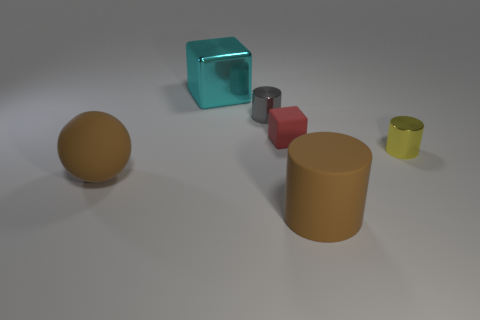There is a yellow shiny thing that is the same size as the gray metal object; what shape is it?
Provide a short and direct response. Cylinder. Is the number of big metallic things less than the number of brown matte objects?
Make the answer very short. Yes. Is there a brown cylinder that is left of the rubber thing in front of the brown ball?
Offer a very short reply. No. Is there a tiny gray metal object that is in front of the big object that is behind the metal cylinder behind the matte block?
Your answer should be compact. Yes. Is the shape of the large brown rubber thing to the right of the small gray metal object the same as the metal thing in front of the red rubber cube?
Keep it short and to the point. Yes. There is a large thing that is the same material as the small yellow cylinder; what is its color?
Your response must be concise. Cyan. Is the number of metallic objects on the right side of the small gray thing less than the number of large rubber balls?
Keep it short and to the point. No. There is a cylinder to the right of the large object in front of the brown thing that is on the left side of the tiny gray shiny thing; how big is it?
Offer a very short reply. Small. Do the large object that is left of the big cube and the cyan block have the same material?
Provide a short and direct response. No. There is a large object that is the same color as the matte cylinder; what is its material?
Provide a short and direct response. Rubber. 